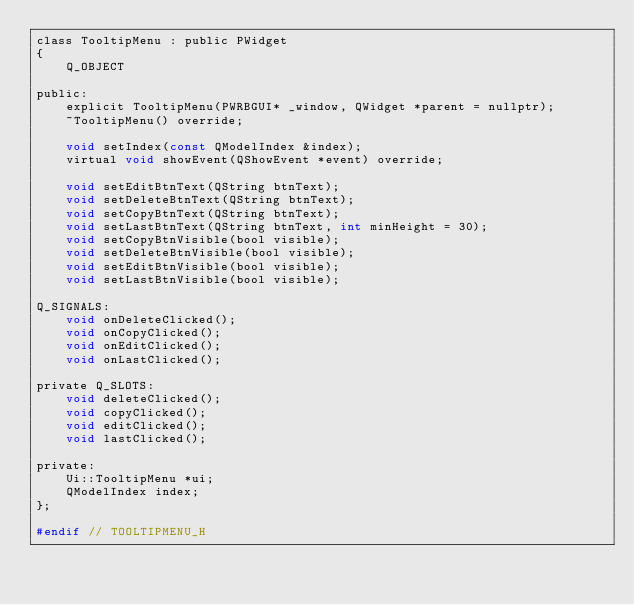<code> <loc_0><loc_0><loc_500><loc_500><_C_>class TooltipMenu : public PWidget
{
    Q_OBJECT

public:
    explicit TooltipMenu(PWRBGUI* _window, QWidget *parent = nullptr);
    ~TooltipMenu() override;

    void setIndex(const QModelIndex &index);
    virtual void showEvent(QShowEvent *event) override;

    void setEditBtnText(QString btnText);
    void setDeleteBtnText(QString btnText);
    void setCopyBtnText(QString btnText);
    void setLastBtnText(QString btnText, int minHeight = 30);
    void setCopyBtnVisible(bool visible);
    void setDeleteBtnVisible(bool visible);
    void setEditBtnVisible(bool visible);
    void setLastBtnVisible(bool visible);

Q_SIGNALS:
    void onDeleteClicked();
    void onCopyClicked();
    void onEditClicked();
    void onLastClicked();

private Q_SLOTS:
    void deleteClicked();
    void copyClicked();
    void editClicked();
    void lastClicked();

private:
    Ui::TooltipMenu *ui;
    QModelIndex index;
};

#endif // TOOLTIPMENU_H
</code> 